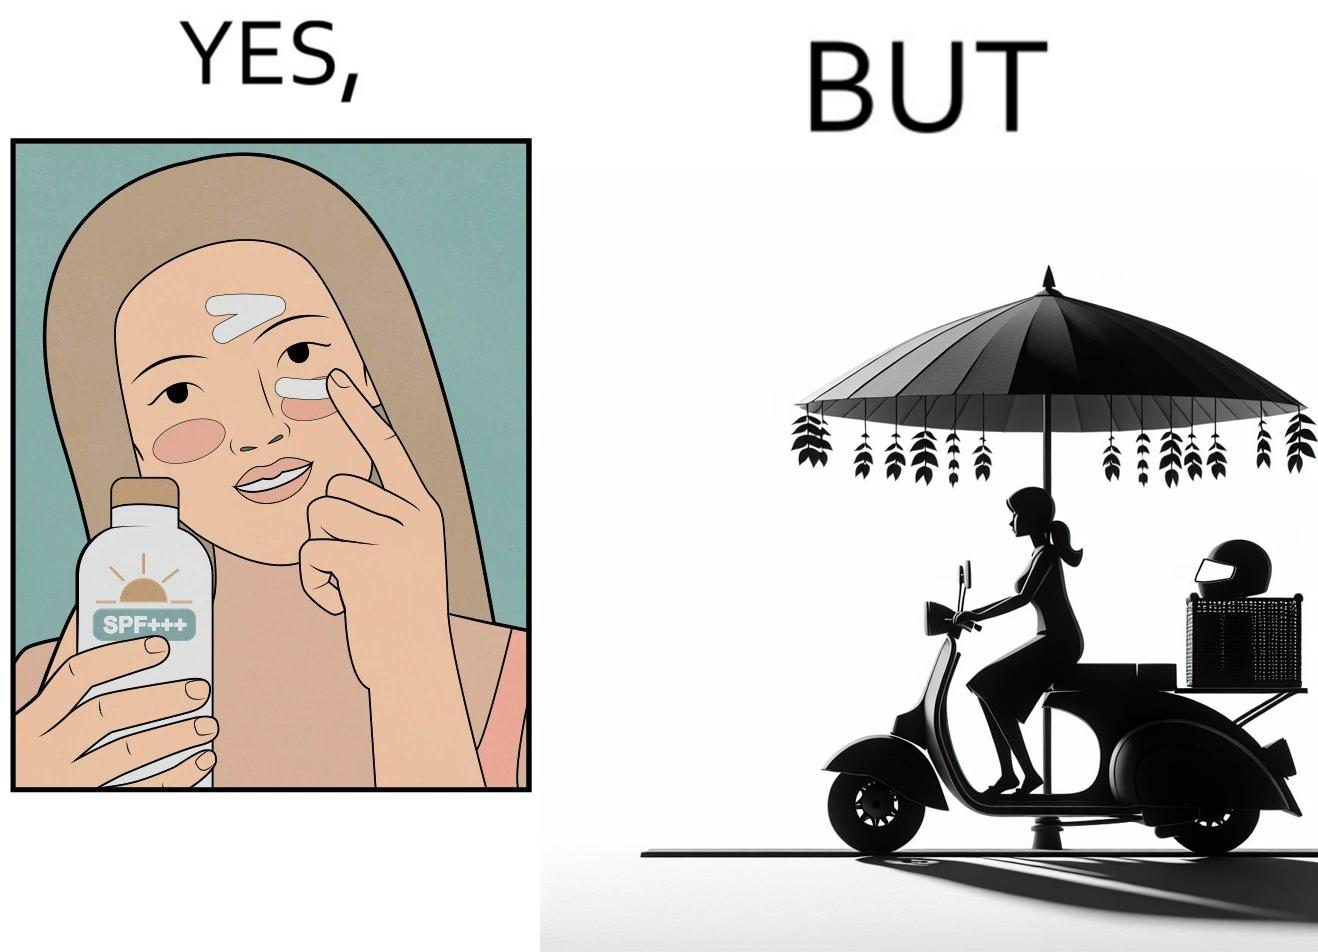Explain the humor or irony in this image. The image is funny because while the woman is concerned about protection from the sun rays, she is not concerned about her safety while riding a scooter. 